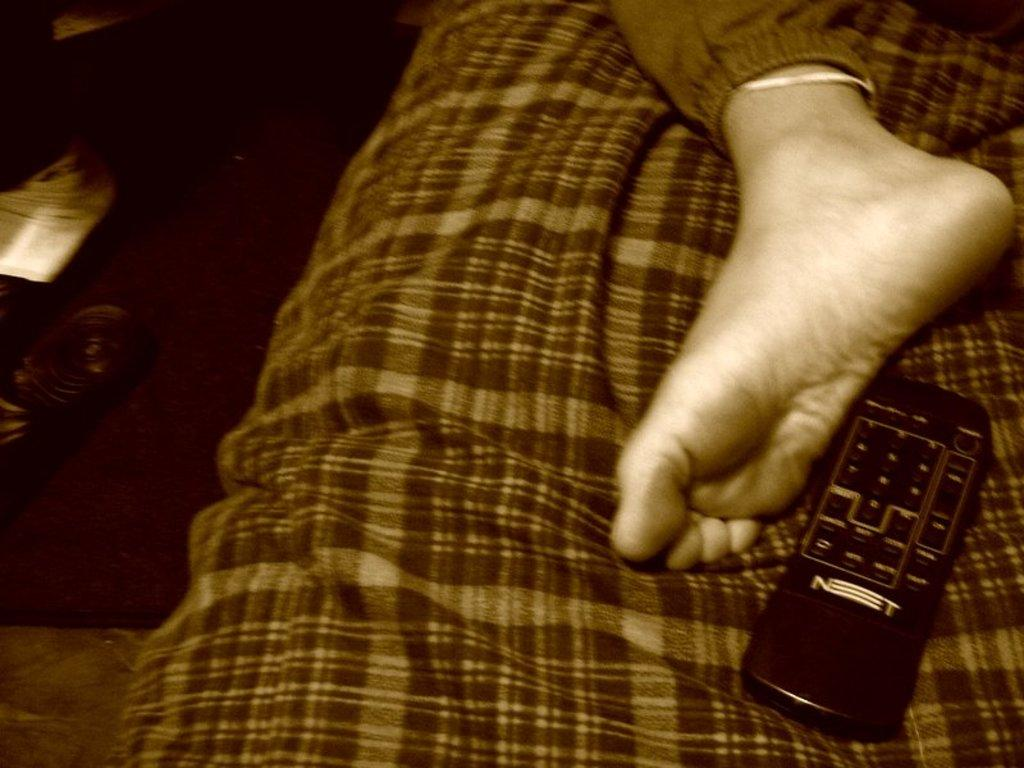<image>
Offer a succinct explanation of the picture presented. A foot is visible next to an NT branded remote control. 